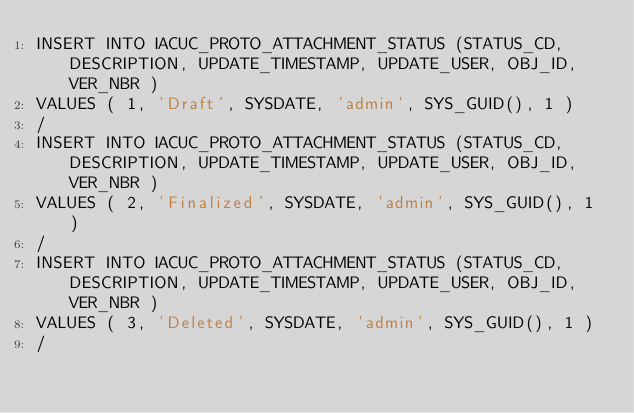<code> <loc_0><loc_0><loc_500><loc_500><_SQL_>INSERT INTO IACUC_PROTO_ATTACHMENT_STATUS (STATUS_CD, DESCRIPTION, UPDATE_TIMESTAMP, UPDATE_USER, OBJ_ID, VER_NBR ) 
VALUES ( 1, 'Draft', SYSDATE, 'admin', SYS_GUID(), 1 ) 
/
INSERT INTO IACUC_PROTO_ATTACHMENT_STATUS (STATUS_CD, DESCRIPTION, UPDATE_TIMESTAMP, UPDATE_USER, OBJ_ID, VER_NBR ) 
VALUES ( 2, 'Finalized', SYSDATE, 'admin', SYS_GUID(), 1 ) 
/
INSERT INTO IACUC_PROTO_ATTACHMENT_STATUS (STATUS_CD, DESCRIPTION, UPDATE_TIMESTAMP, UPDATE_USER, OBJ_ID, VER_NBR ) 
VALUES ( 3, 'Deleted', SYSDATE, 'admin', SYS_GUID(), 1 ) 
/</code> 